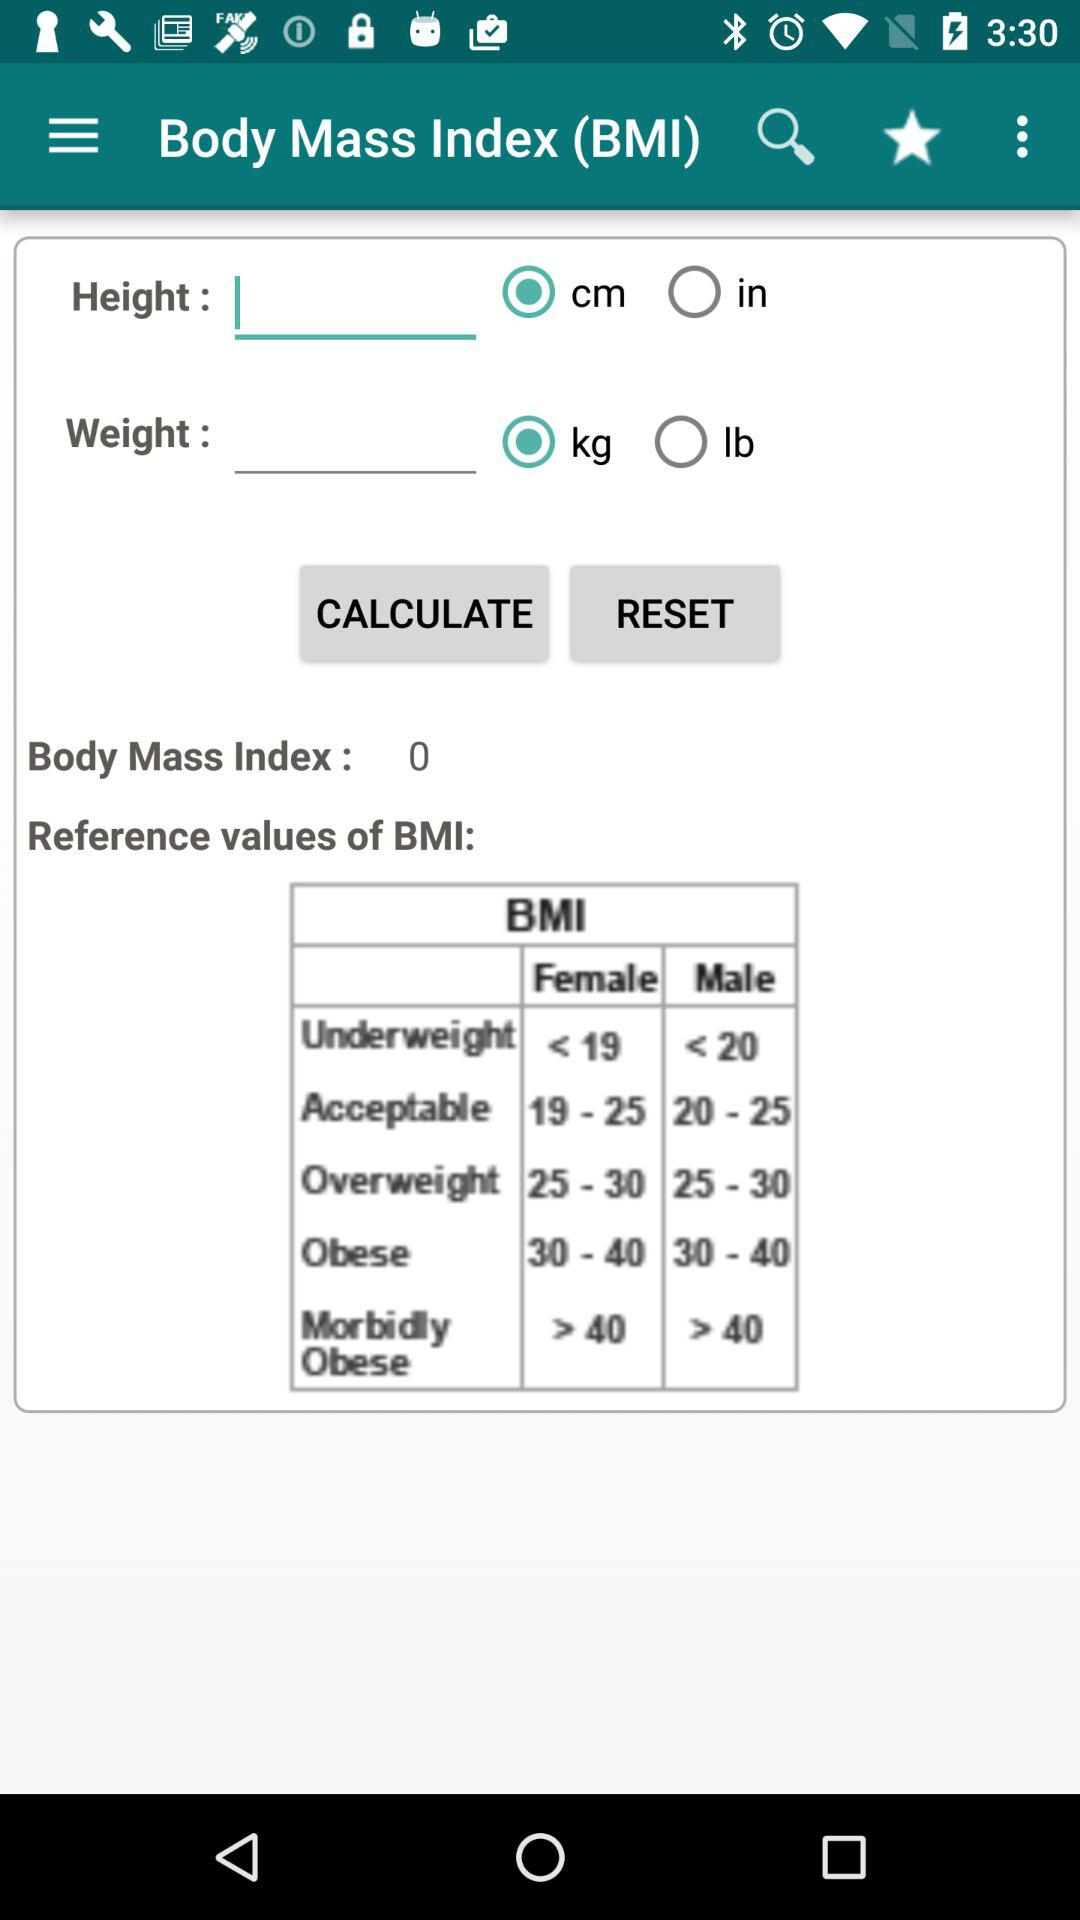What is the BMI value for a female if she is underweight? The BMI value is less than 19. 